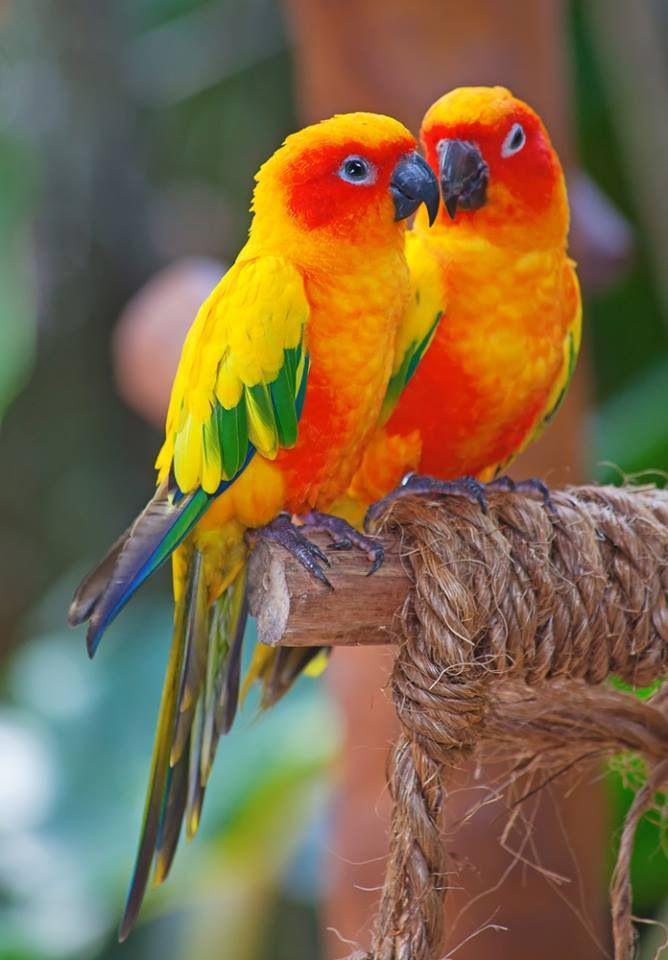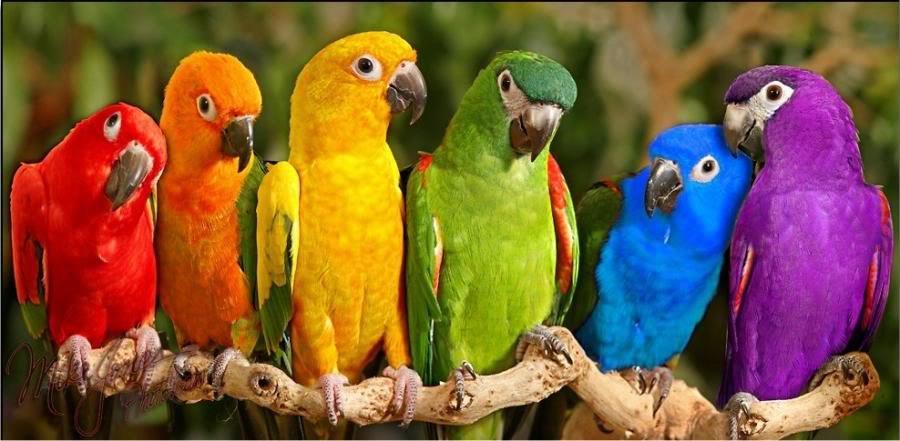The first image is the image on the left, the second image is the image on the right. Examine the images to the left and right. Is the description "One of the images has only two parrots." accurate? Answer yes or no. Yes. The first image is the image on the left, the second image is the image on the right. Analyze the images presented: Is the assertion "There are at least 2 blue-headed parrots." valid? Answer yes or no. No. 